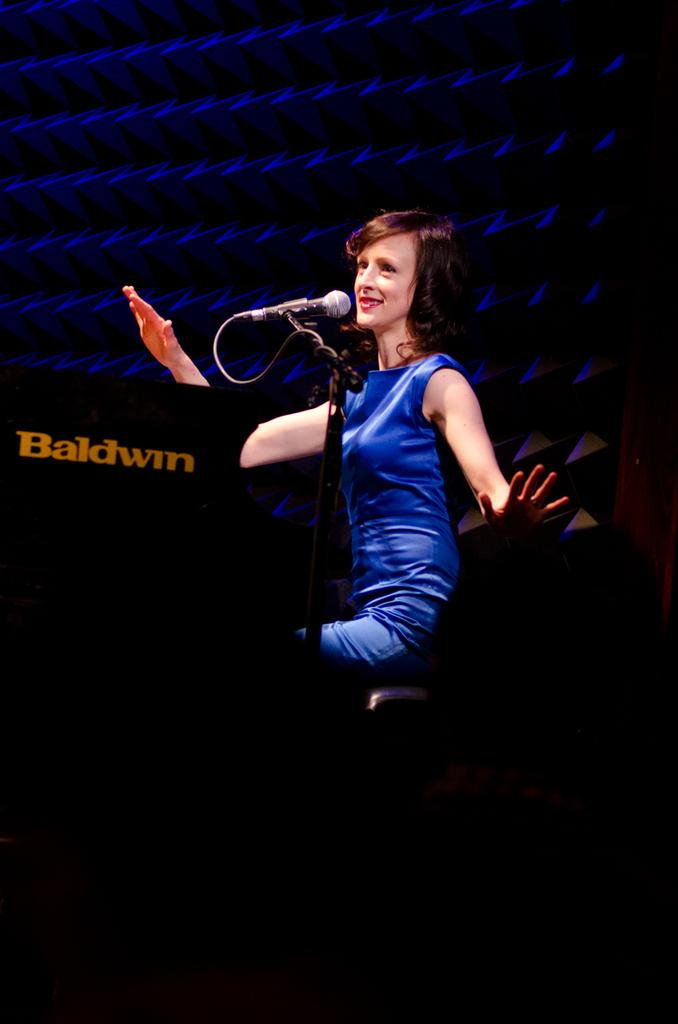Who is the main subject in the image? There is a woman in the image. What is the woman doing in the image? The woman is sitting on a chair. What can be seen on the left side of the image? There is a mic stand on the left side of the image. What is attached to the mic stand? There is a microphone on the mic stand. What type of feeling can be seen on the woman's face in the image? The image does not provide information about the woman's facial expression or feelings. 